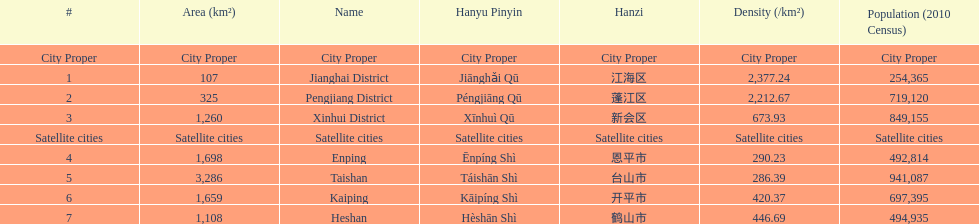Which area has the largest population? Taishan. 